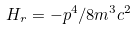Convert formula to latex. <formula><loc_0><loc_0><loc_500><loc_500>H _ { r } = - p ^ { 4 } / 8 m ^ { 3 } c ^ { 2 }</formula> 